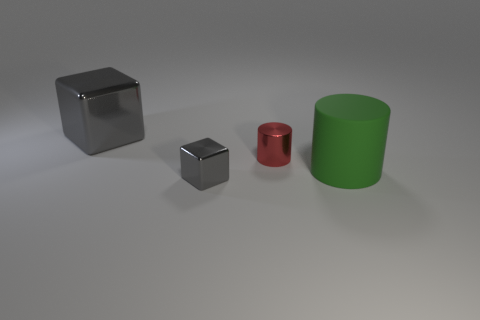What shape is the tiny red shiny object?
Offer a very short reply. Cylinder. Does the large thing that is in front of the big shiny object have the same color as the small metal cylinder?
Make the answer very short. No. The thing that is in front of the red metallic object and on the left side of the big green cylinder has what shape?
Give a very brief answer. Cube. What is the color of the cube in front of the tiny red metal object?
Provide a short and direct response. Gray. Are there any other things that are the same color as the metal cylinder?
Your answer should be compact. No. Does the red cylinder have the same size as the green object?
Your response must be concise. No. How big is the thing that is both behind the big green cylinder and left of the red metal thing?
Your response must be concise. Large. How many green things are the same material as the tiny red cylinder?
Provide a succinct answer. 0. The big metallic block is what color?
Make the answer very short. Gray. Is the shape of the object that is right of the tiny metallic cylinder the same as  the large gray metal object?
Your answer should be compact. No. 